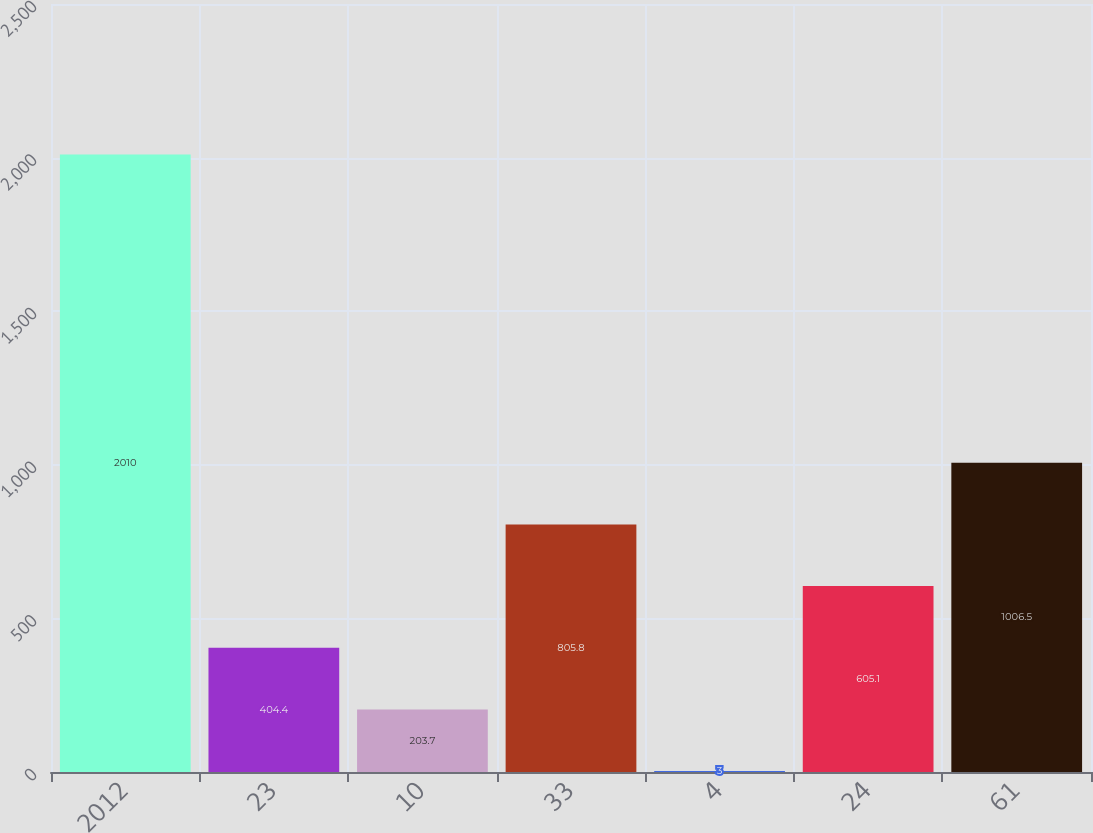<chart> <loc_0><loc_0><loc_500><loc_500><bar_chart><fcel>2012<fcel>23<fcel>10<fcel>33<fcel>4<fcel>24<fcel>61<nl><fcel>2010<fcel>404.4<fcel>203.7<fcel>805.8<fcel>3<fcel>605.1<fcel>1006.5<nl></chart> 